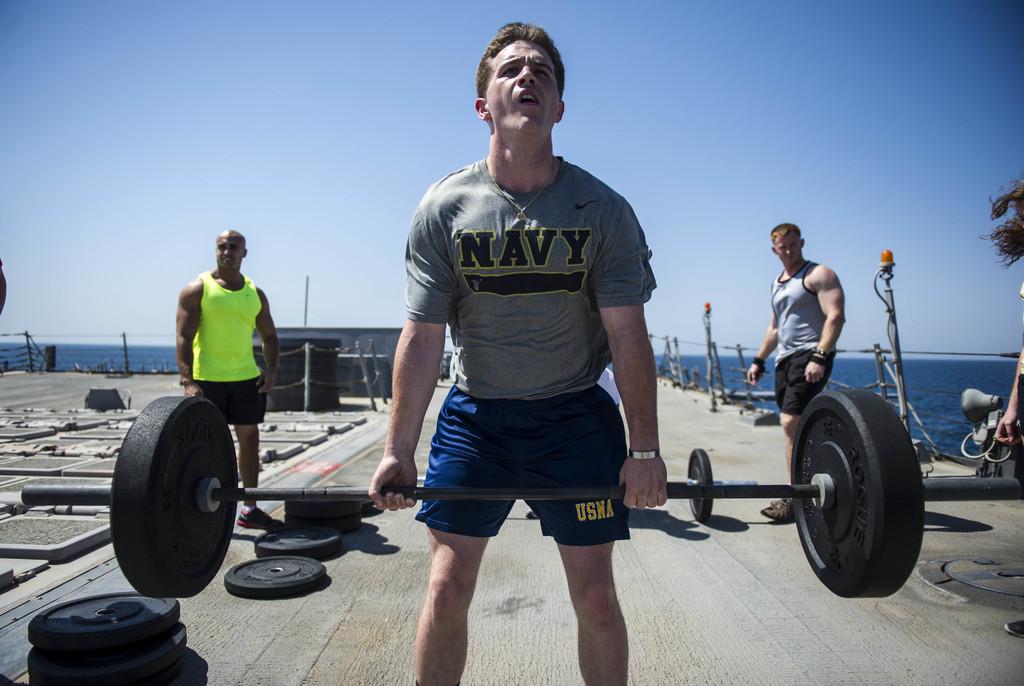What branch of the military is the weightlifter in?
Offer a very short reply. Navy. What branch is on the shorts?
Your response must be concise. Usna. 